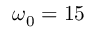<formula> <loc_0><loc_0><loc_500><loc_500>\omega _ { 0 } = 1 5</formula> 